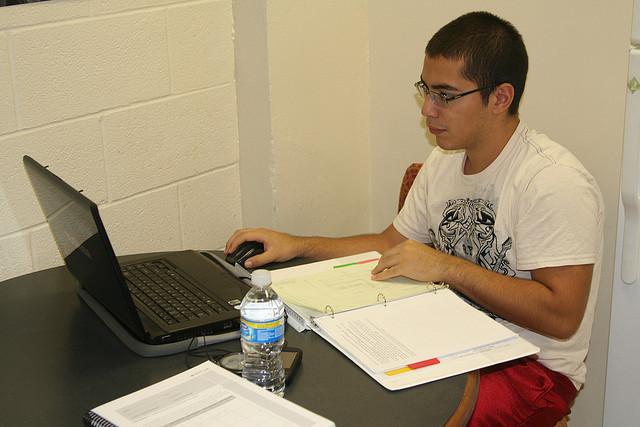Is this a Nintendo Wii controller?
Quick response, please. No. Is the man cooking?
Keep it brief. No. How many computers are in this photo?
Quick response, please. 1. How many people are looking at laptops?
Be succinct. 1. Are there dividers in the notebook?
Write a very short answer. Yes. What is he holding in his hands?
Keep it brief. Mouse. Is the work area neatly arranged?
Give a very brief answer. Yes. Who took this photo?
Give a very brief answer. Person. Does this person have a writing utensil?
Be succinct. No. 